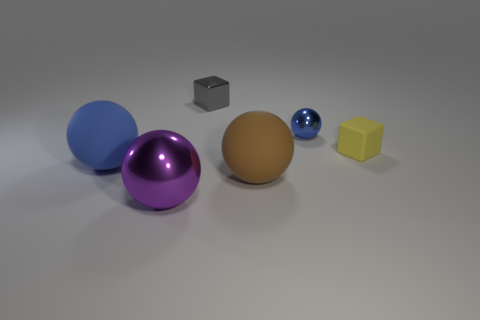What size is the gray thing?
Provide a succinct answer. Small. Are there more gray cubes that are on the left side of the gray block than small blue metal things right of the tiny blue thing?
Offer a very short reply. No. Are there any rubber things in front of the small yellow thing?
Provide a succinct answer. Yes. Are there any blue rubber spheres of the same size as the blue rubber thing?
Your response must be concise. No. What is the color of the tiny ball that is the same material as the tiny gray thing?
Make the answer very short. Blue. What is the material of the large blue ball?
Provide a short and direct response. Rubber. What shape is the small matte object?
Keep it short and to the point. Cube. What number of cylinders are the same color as the small sphere?
Keep it short and to the point. 0. What material is the tiny cube that is right of the small cube that is on the left side of the cube that is to the right of the gray metallic block made of?
Ensure brevity in your answer.  Rubber. How many gray objects are either cubes or small objects?
Offer a terse response. 1. 